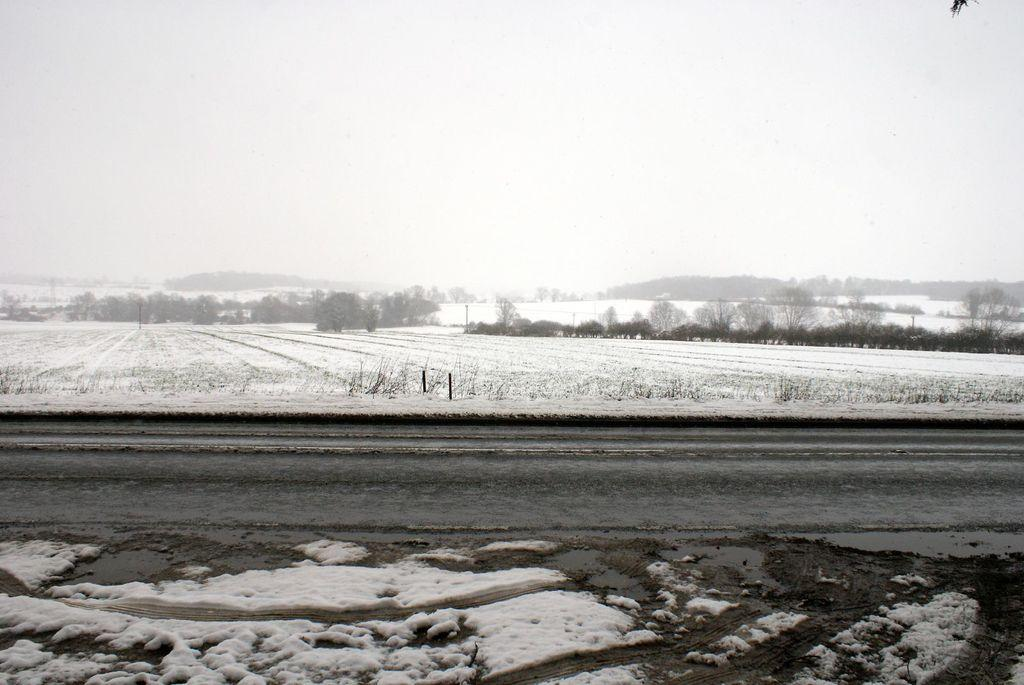What type of weather is depicted in the image? There is snow in the image, indicating cold weather. What can be seen on the ground in the image? There is a road in the image. What is visible in the background of the image? Trees are visible in the background of the image. What type of toy can be seen hanging from the trees in the image? There is no toy present in the image; it only features snow, a road, and trees. 